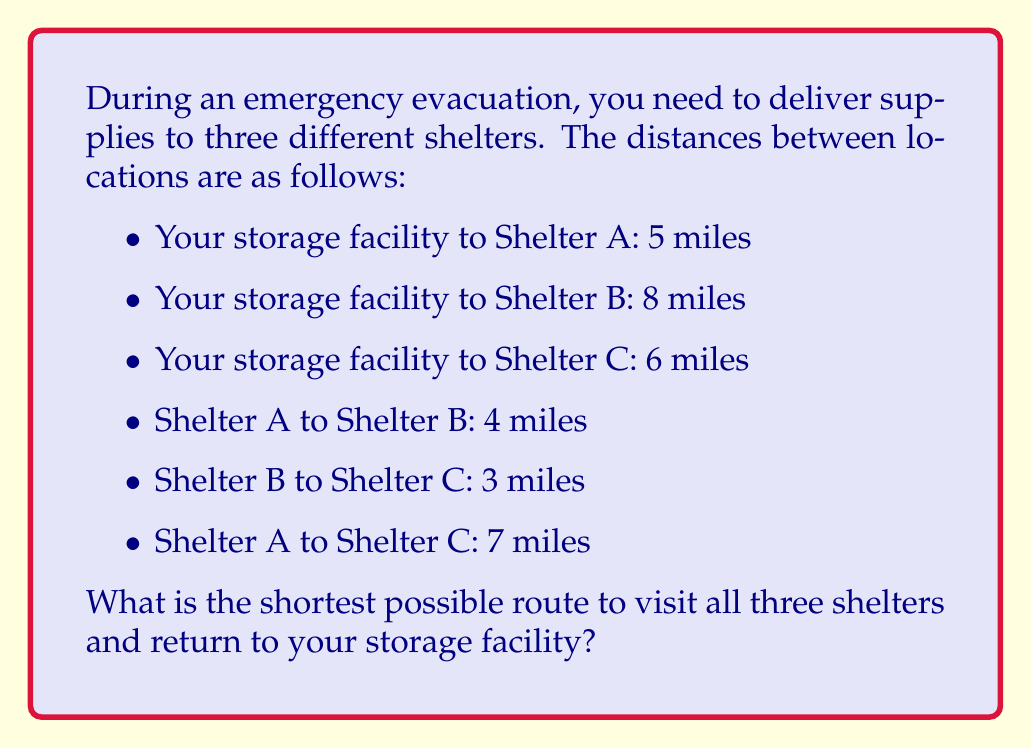Can you answer this question? To find the shortest route, we need to consider all possible combinations and calculate their total distances:

1. Storage → A → B → C → Storage
   Distance = $5 + 4 + 3 + 6 = 18$ miles

2. Storage → A → C → B → Storage
   Distance = $5 + 7 + 3 + 8 = 23$ miles

3. Storage → B → A → C → Storage
   Distance = $8 + 4 + 7 + 6 = 25$ miles

4. Storage → B → C → A → Storage
   Distance = $8 + 3 + 7 + 5 = 23$ miles

5. Storage → C → A → B → Storage
   Distance = $6 + 7 + 4 + 8 = 25$ miles

6. Storage → C → B → A → Storage
   Distance = $6 + 3 + 4 + 5 = 18$ miles

The shortest routes are options 1 and 6, both with a total distance of 18 miles. We can choose either one as the optimal route.
Answer: 18 miles (Storage → A → B → C → Storage or Storage → C → B → A → Storage) 